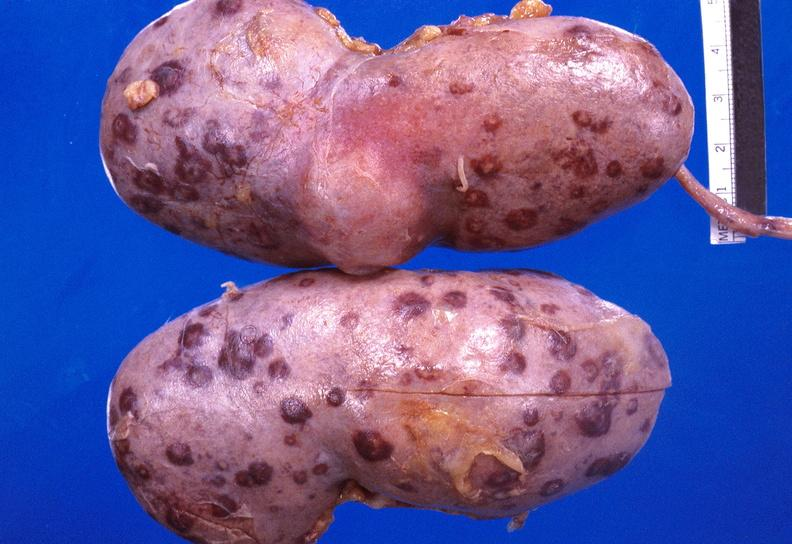what does this image show?
Answer the question using a single word or phrase. Kidney candida abscesses from patient with acute myelogenous leukemia 